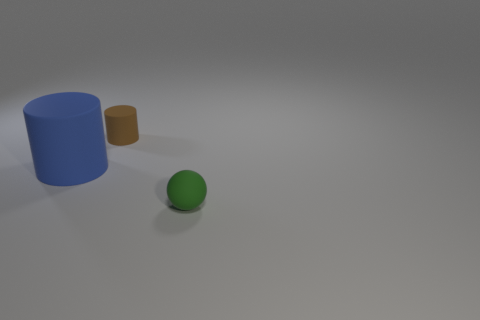Add 1 small cyan rubber blocks. How many objects exist? 4 Subtract all cylinders. How many objects are left? 1 Add 2 small rubber cylinders. How many small rubber cylinders exist? 3 Subtract 0 brown balls. How many objects are left? 3 Subtract all big red metal balls. Subtract all small rubber balls. How many objects are left? 2 Add 1 matte balls. How many matte balls are left? 2 